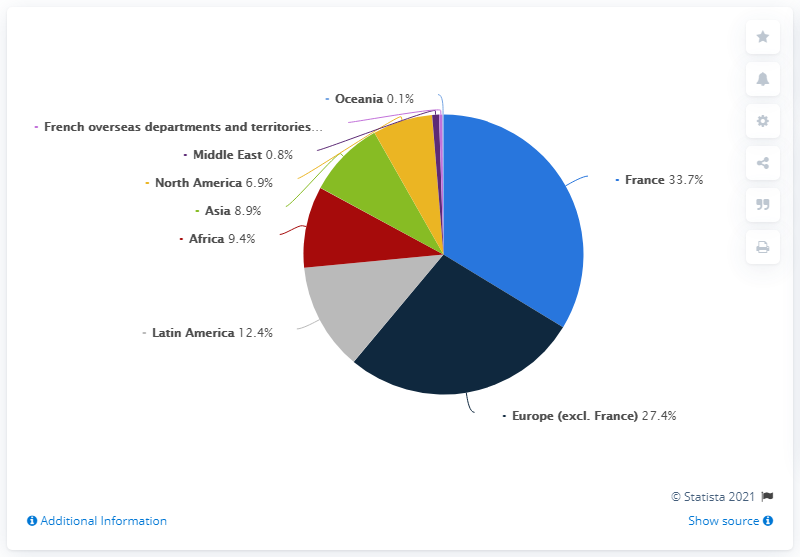Specify some key components in this picture. Out of the regions analyzed, two exceeded a 20% distribution. In 2019, Latin America accounted for 12.4% of Total S.A.'s global workforce. 